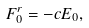<formula> <loc_0><loc_0><loc_500><loc_500>F _ { 0 } ^ { r } = - c E _ { 0 } ,</formula> 